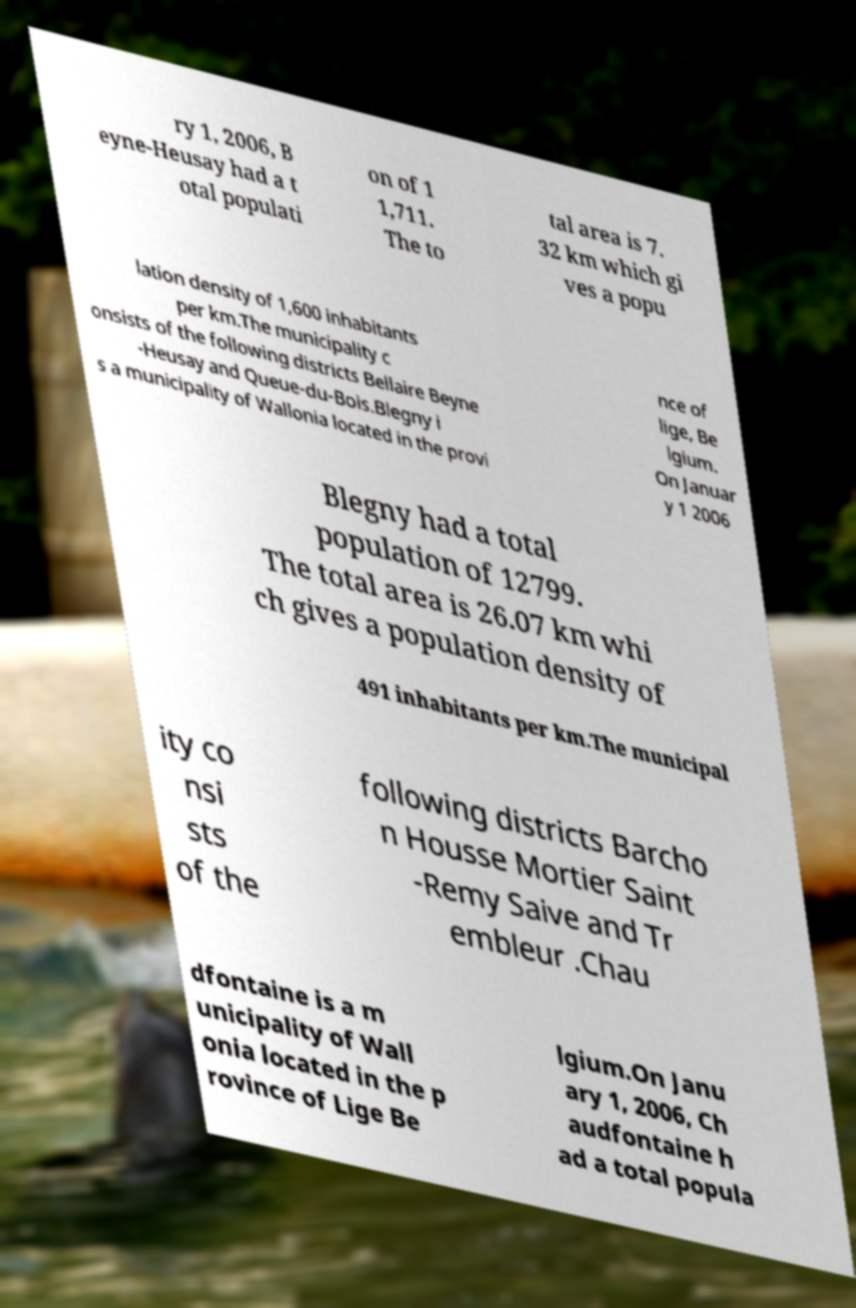Please identify and transcribe the text found in this image. ry 1, 2006, B eyne-Heusay had a t otal populati on of 1 1,711. The to tal area is 7. 32 km which gi ves a popu lation density of 1,600 inhabitants per km.The municipality c onsists of the following districts Bellaire Beyne -Heusay and Queue-du-Bois.Blegny i s a municipality of Wallonia located in the provi nce of lige, Be lgium. On Januar y 1 2006 Blegny had a total population of 12799. The total area is 26.07 km whi ch gives a population density of 491 inhabitants per km.The municipal ity co nsi sts of the following districts Barcho n Housse Mortier Saint -Remy Saive and Tr embleur .Chau dfontaine is a m unicipality of Wall onia located in the p rovince of Lige Be lgium.On Janu ary 1, 2006, Ch audfontaine h ad a total popula 